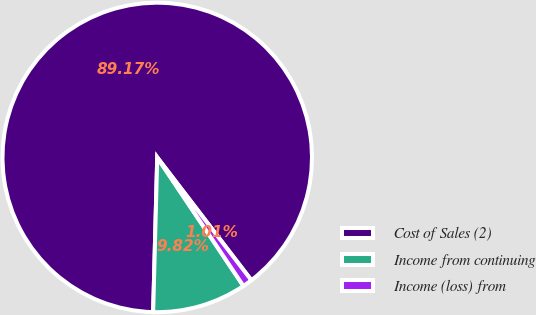<chart> <loc_0><loc_0><loc_500><loc_500><pie_chart><fcel>Cost of Sales (2)<fcel>Income from continuing<fcel>Income (loss) from<nl><fcel>89.17%<fcel>9.82%<fcel>1.01%<nl></chart> 